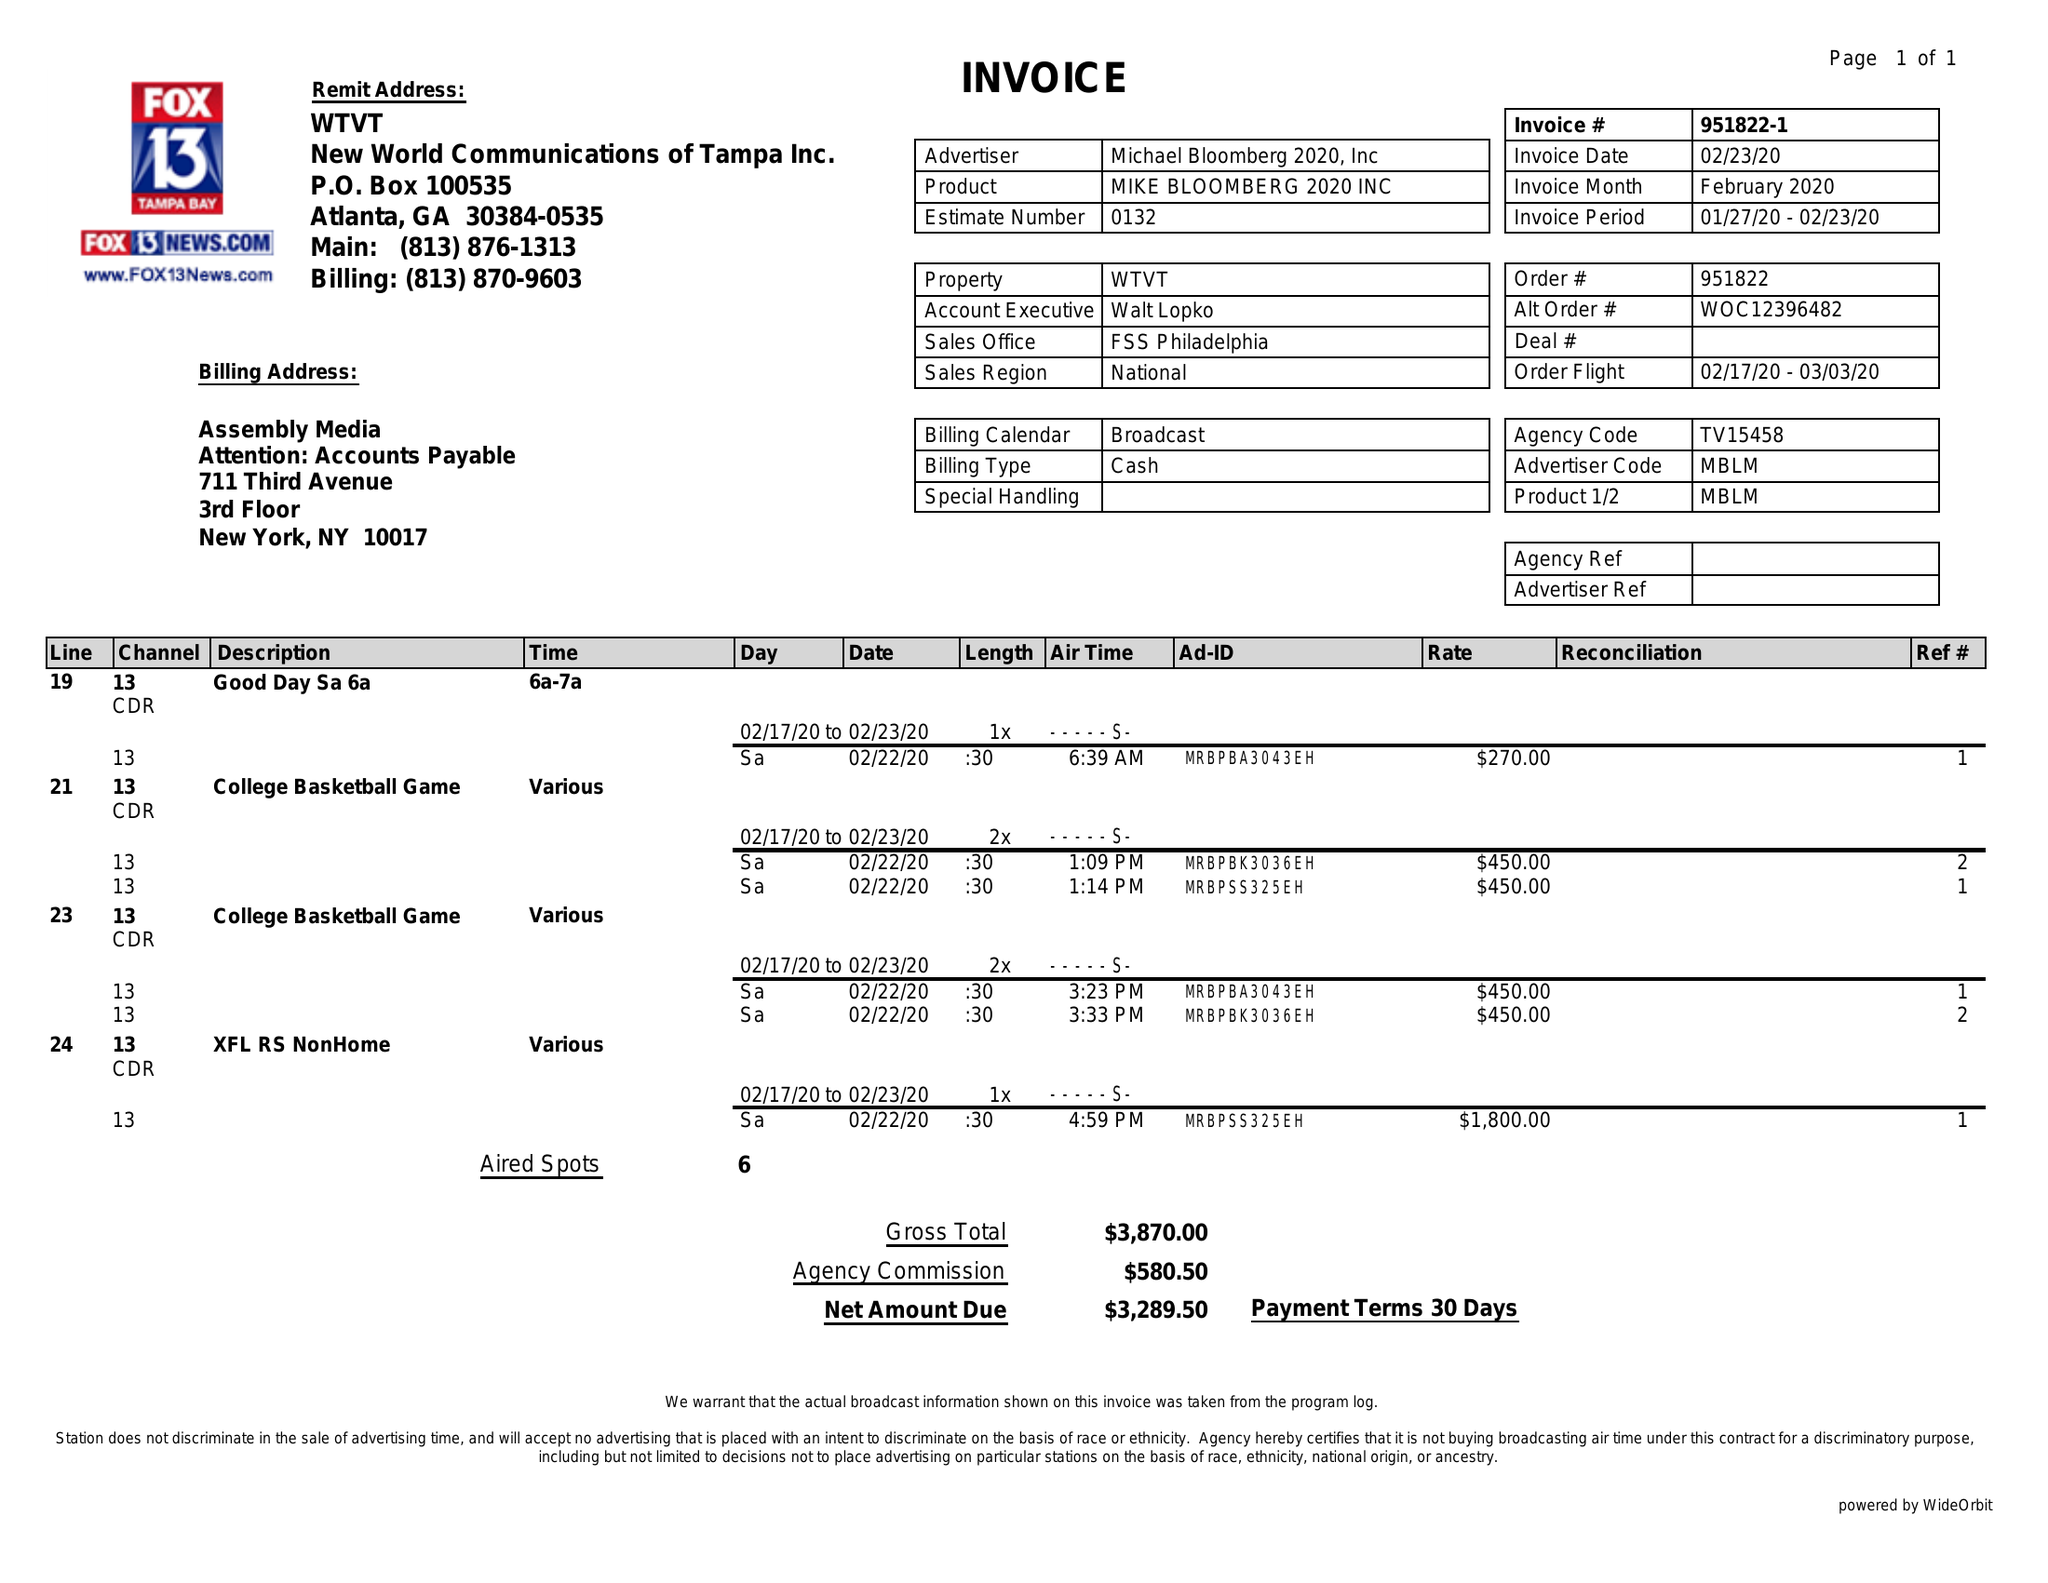What is the value for the contract_num?
Answer the question using a single word or phrase. 951822 